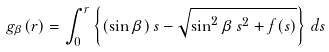Convert formula to latex. <formula><loc_0><loc_0><loc_500><loc_500>g _ { \beta } ( r ) = \int _ { 0 } ^ { r } \left \{ ( \sin \beta ) \, s - \sqrt { \sin ^ { 2 } \beta \, s ^ { 2 } + f ( s ) } \right \} \, d s</formula> 